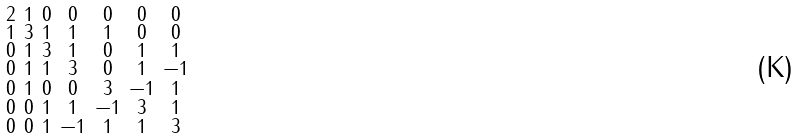Convert formula to latex. <formula><loc_0><loc_0><loc_500><loc_500>\begin{smallmatrix} 2 & 1 & 0 & 0 & 0 & 0 & 0 \\ 1 & 3 & 1 & 1 & 1 & 0 & 0 \\ 0 & 1 & 3 & 1 & 0 & 1 & 1 \\ 0 & 1 & 1 & 3 & 0 & 1 & - 1 \\ 0 & 1 & 0 & 0 & 3 & - 1 & 1 \\ 0 & 0 & 1 & 1 & - 1 & 3 & 1 \\ 0 & 0 & 1 & - 1 & 1 & 1 & 3 \end{smallmatrix}</formula> 